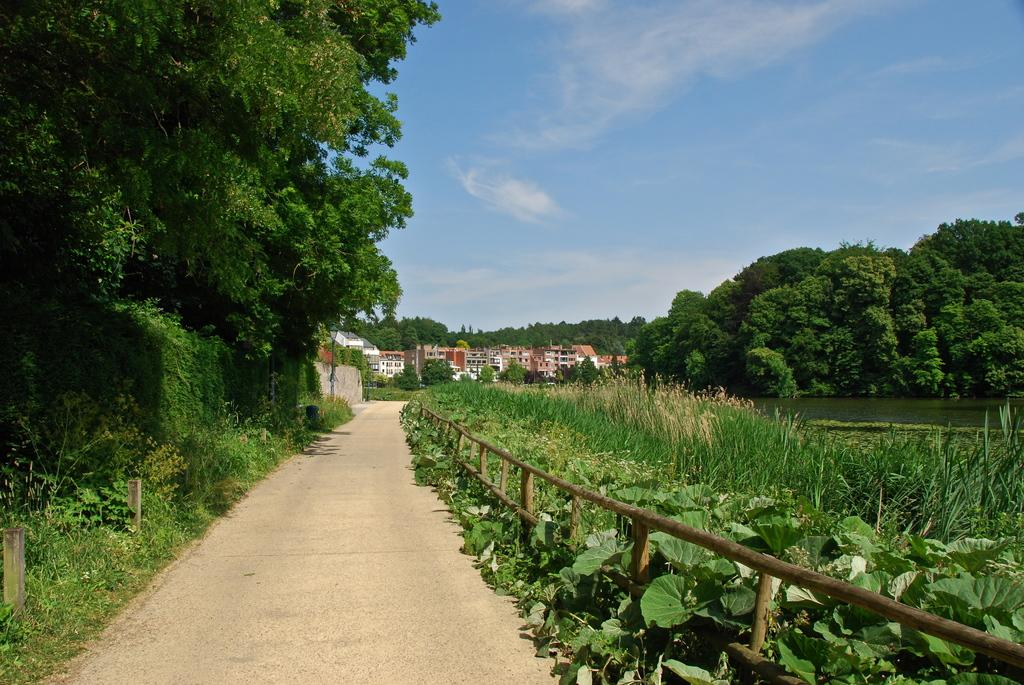What can be seen in the image that people might walk on? There is a path in the image that people might walk on. What type of vegetation is present near the path? There are plants beside the path. What can be seen in the distance in the image? There are buildings and trees in the background of the image. What is visible above the buildings and trees in the image? The sky is visible in the background of the image. What type of story is being told by the shoe in the image? There is no shoe present in the image, so no story can be told by a shoe. 